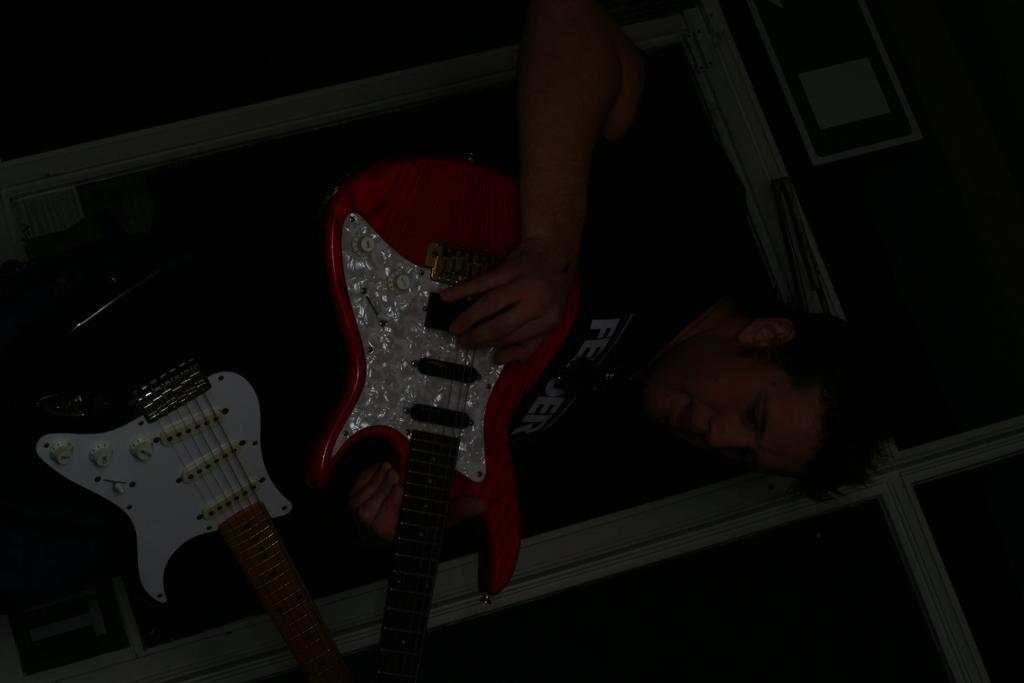Can you describe this image briefly? In this picture there are two guitars which were being handled by a person. In the background there is a wall. 